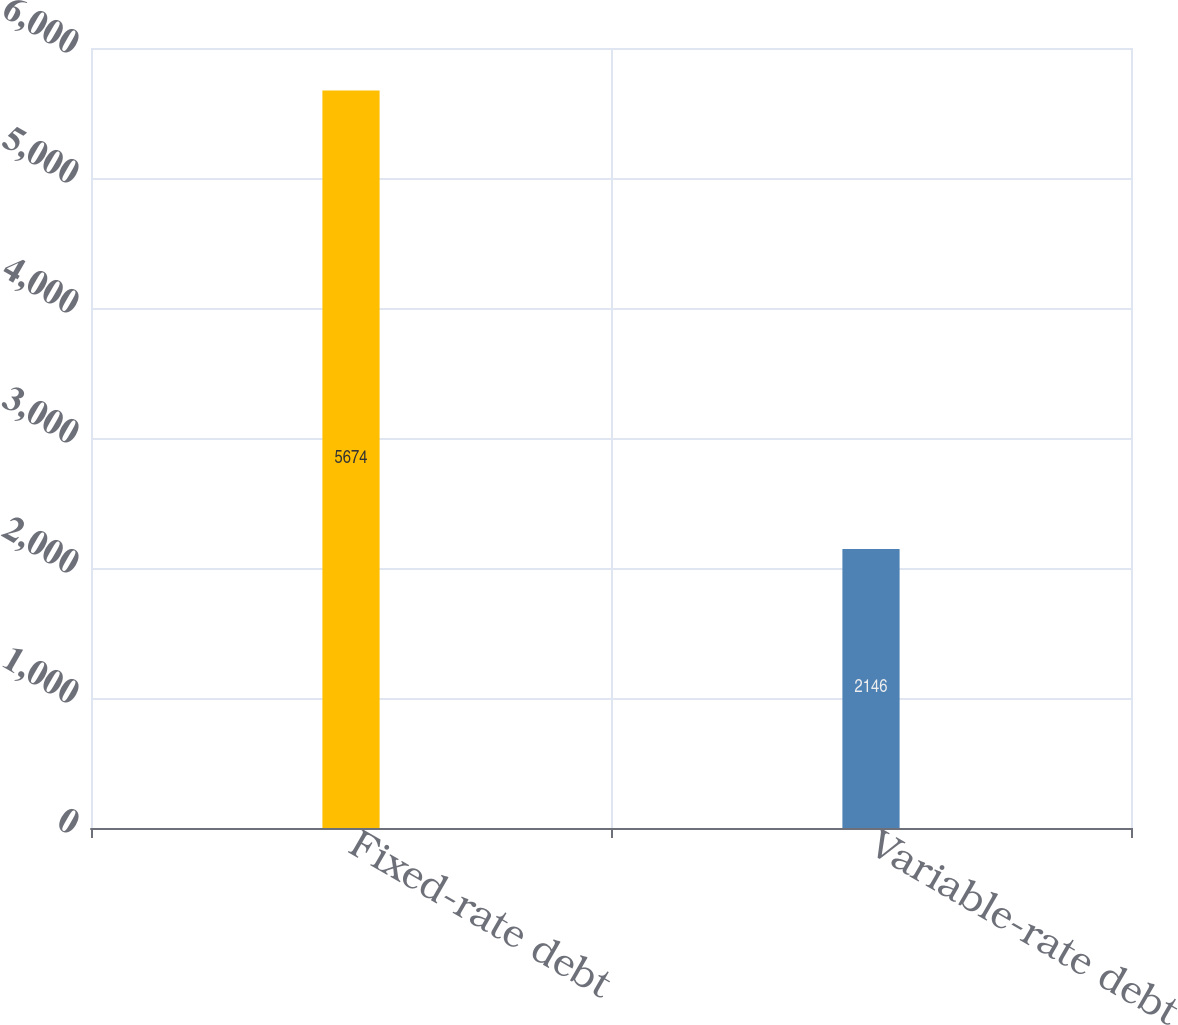Convert chart. <chart><loc_0><loc_0><loc_500><loc_500><bar_chart><fcel>Fixed-rate debt<fcel>Variable-rate debt<nl><fcel>5674<fcel>2146<nl></chart> 